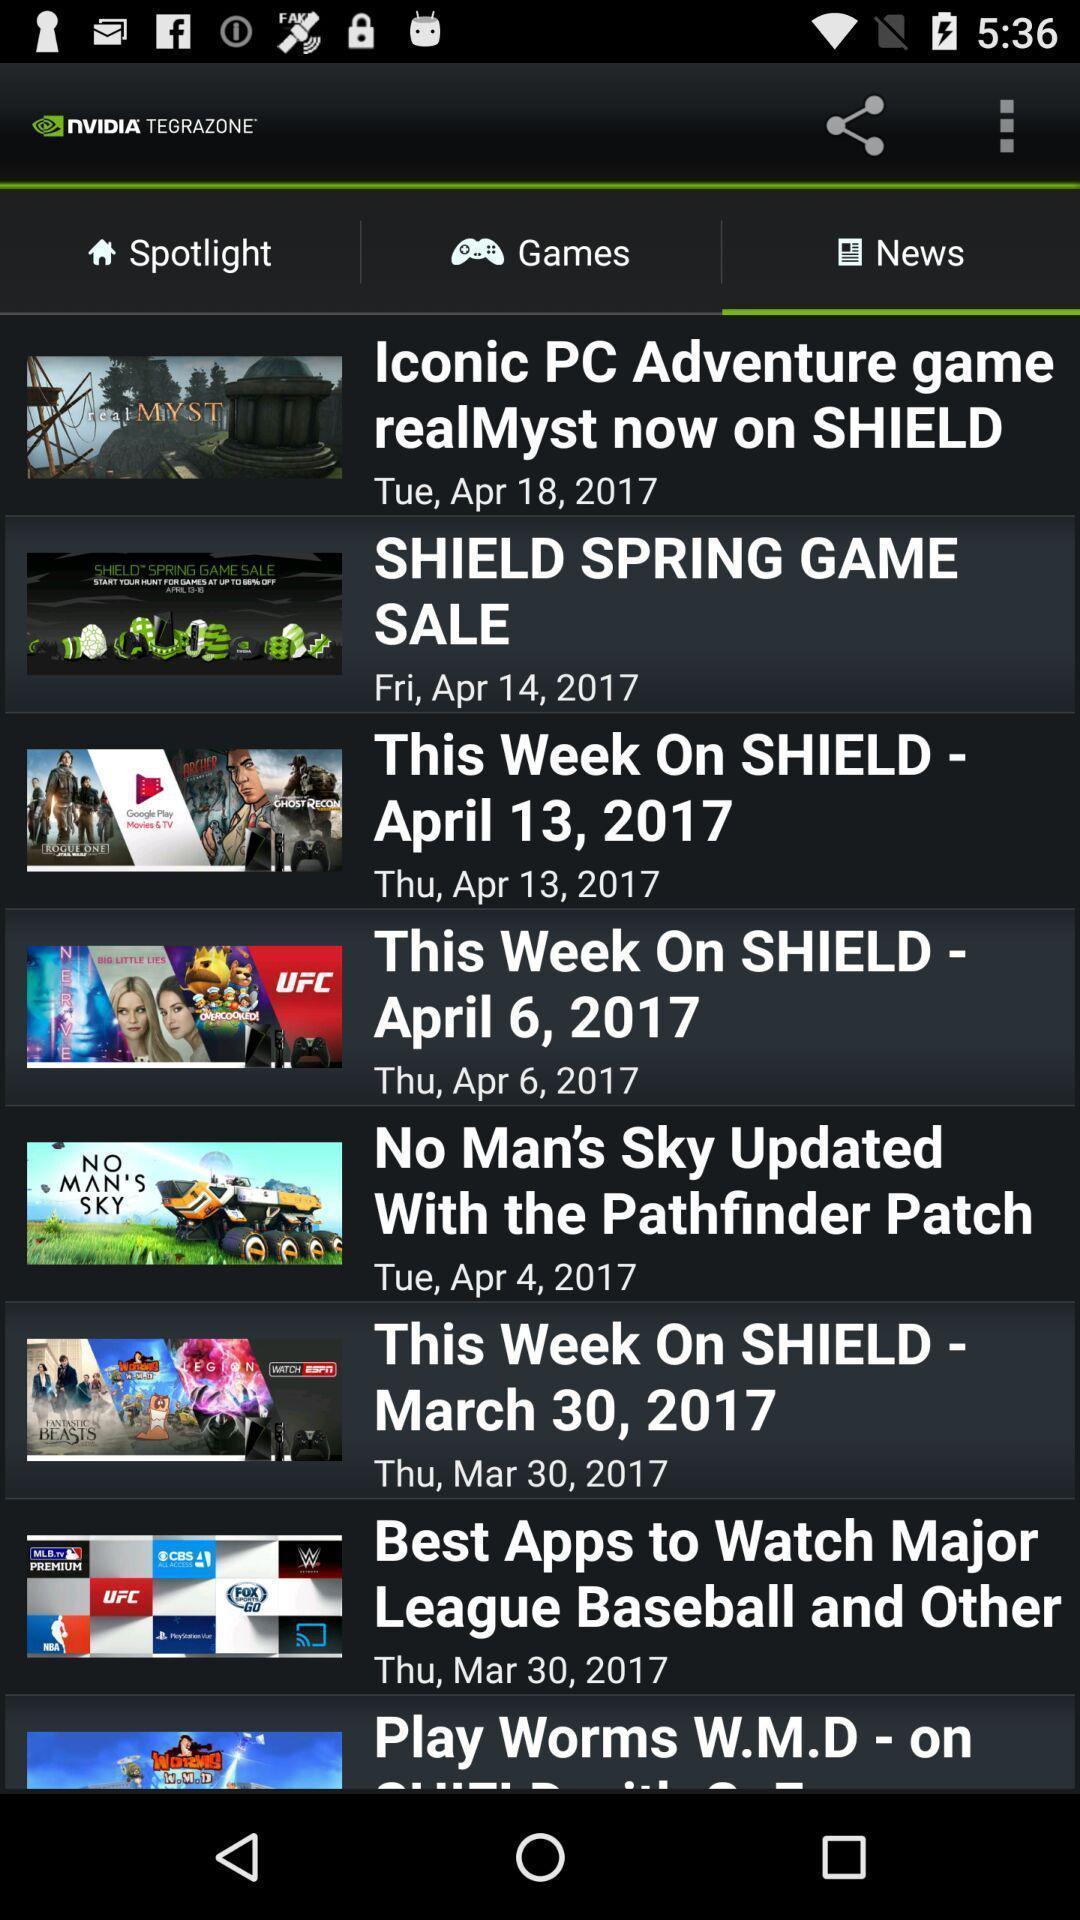Summarize the information in this screenshot. Screen displaying the news page. 